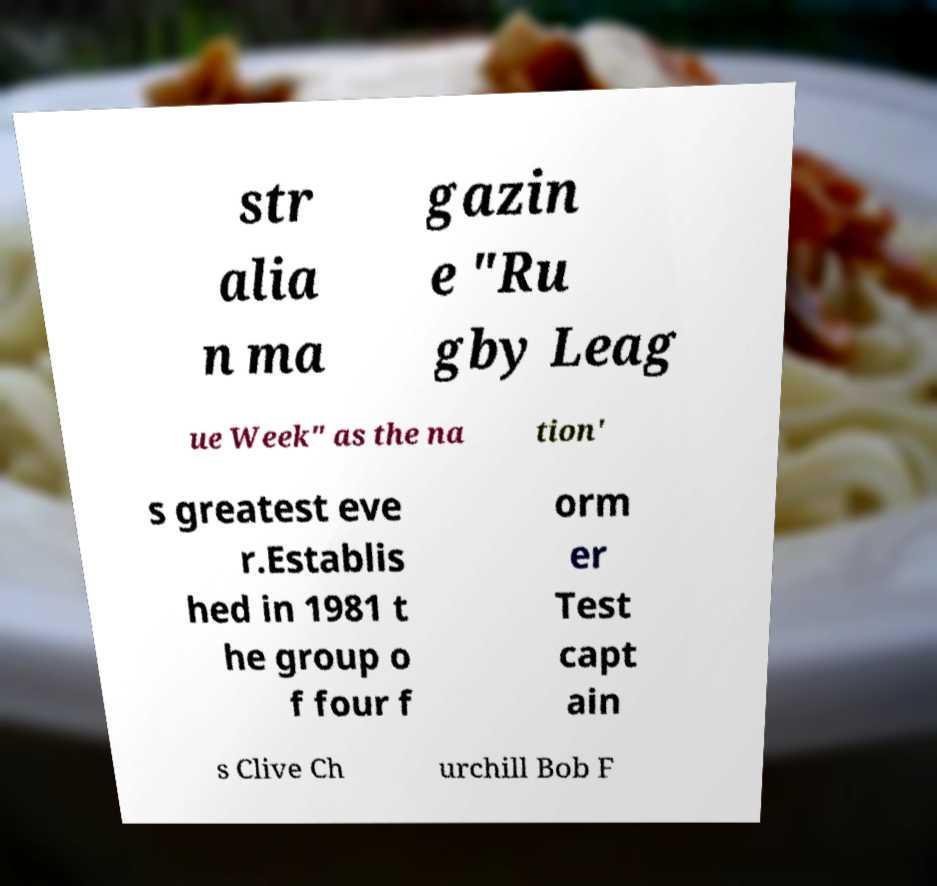Can you accurately transcribe the text from the provided image for me? str alia n ma gazin e "Ru gby Leag ue Week" as the na tion' s greatest eve r.Establis hed in 1981 t he group o f four f orm er Test capt ain s Clive Ch urchill Bob F 